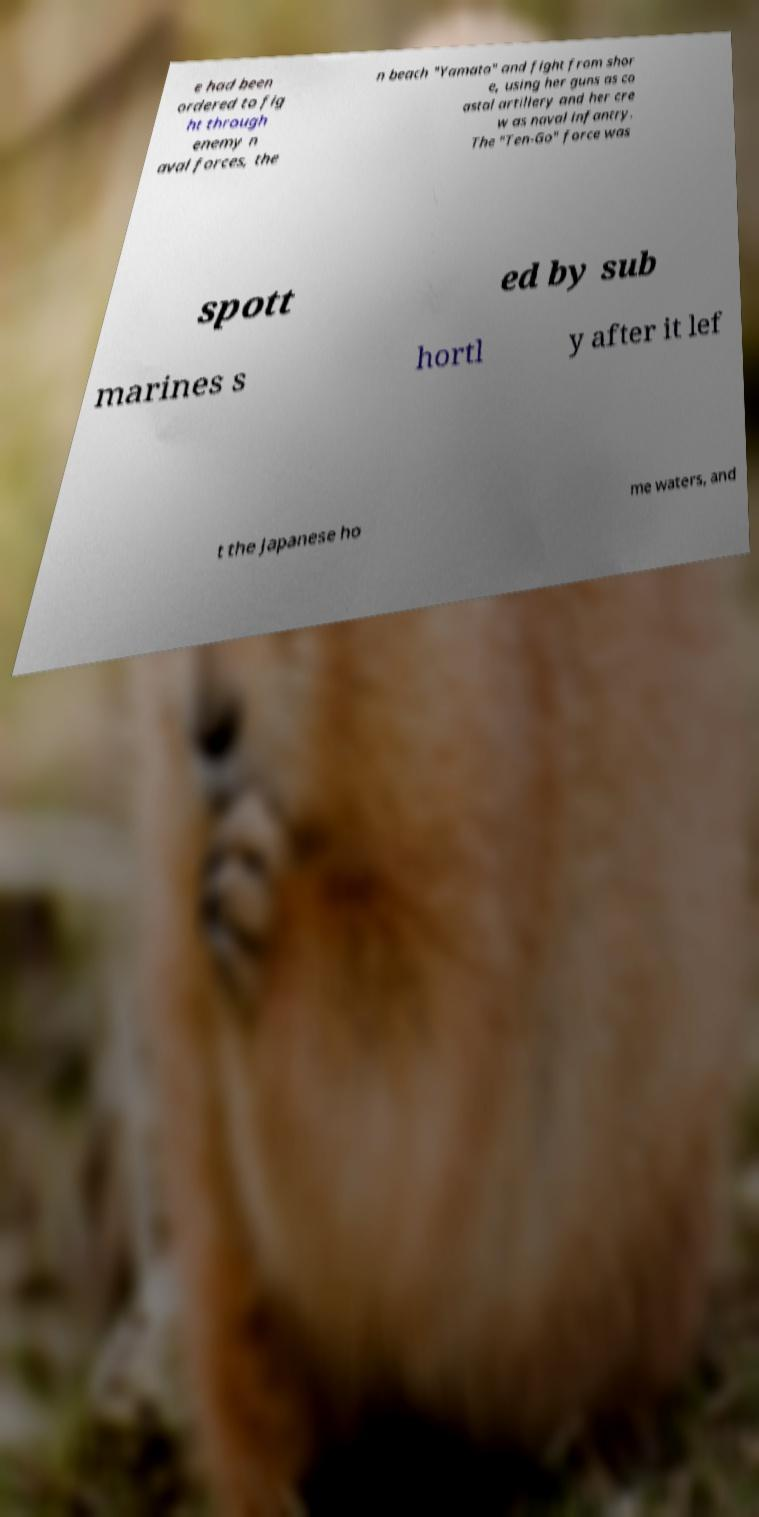Could you extract and type out the text from this image? e had been ordered to fig ht through enemy n aval forces, the n beach "Yamato" and fight from shor e, using her guns as co astal artillery and her cre w as naval infantry. The "Ten-Go" force was spott ed by sub marines s hortl y after it lef t the Japanese ho me waters, and 